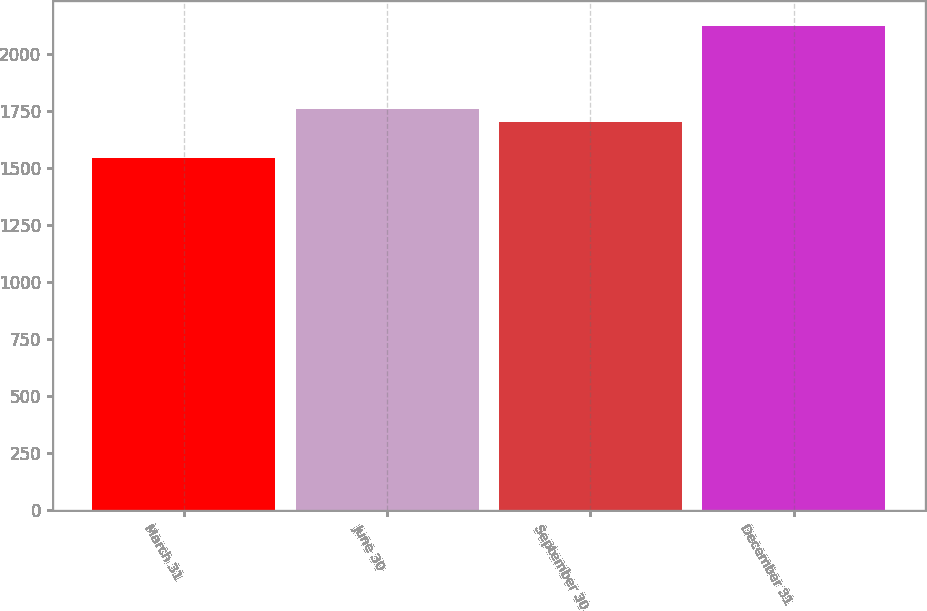<chart> <loc_0><loc_0><loc_500><loc_500><bar_chart><fcel>March 31<fcel>June 30<fcel>September 30<fcel>December 31<nl><fcel>1543<fcel>1758.37<fcel>1700.4<fcel>2122.7<nl></chart> 